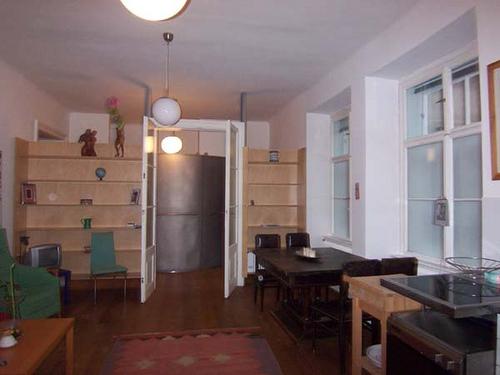Is there a pattern on the ceiling?
Quick response, please. No. Are the lights on in this picture?
Short answer required. Yes. How many chairs are in the room?
Short answer required. 6. How many windows are there?
Be succinct. 2. 